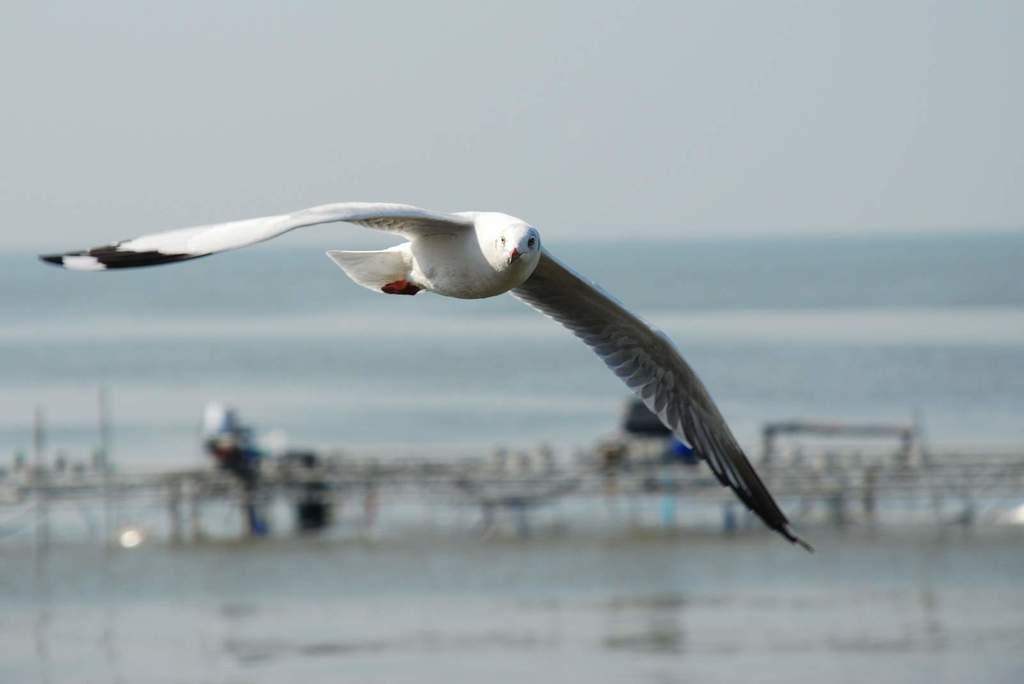What type of bird is in the image? There is a Great black-backed gull in the image. What is the bird doing in the image? The gull is flying in the air. What can be seen behind the bird? There are other objects behind the gull. What is visible in the background of the image? There is water visible in the background of the image. What type of error can be seen in the image? There is no error present in the image; it is a clear photograph of a Great black-backed gull flying in the air. 